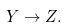<formula> <loc_0><loc_0><loc_500><loc_500>Y \rightarrow Z .</formula> 